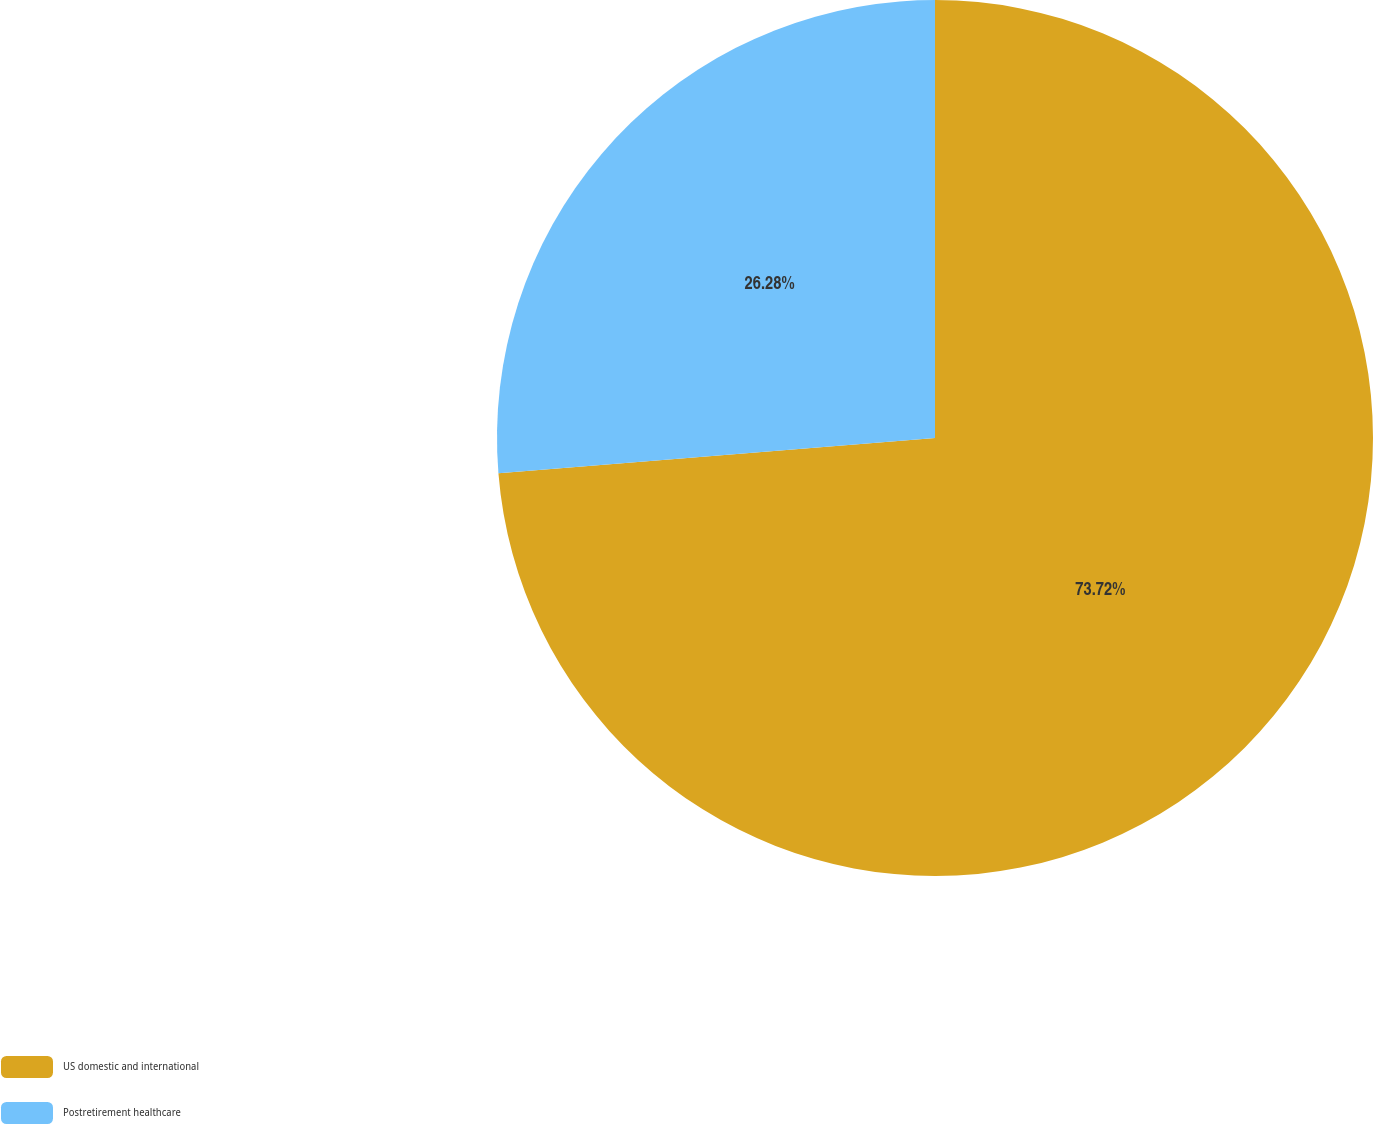<chart> <loc_0><loc_0><loc_500><loc_500><pie_chart><fcel>US domestic and international<fcel>Postretirement healthcare<nl><fcel>73.72%<fcel>26.28%<nl></chart> 